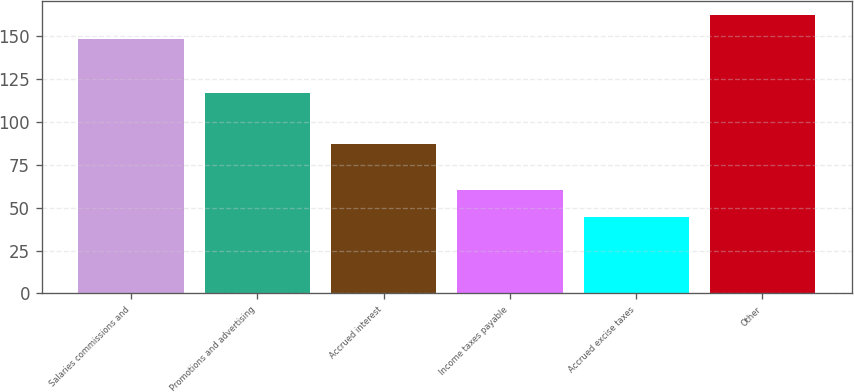Convert chart to OTSL. <chart><loc_0><loc_0><loc_500><loc_500><bar_chart><fcel>Salaries commissions and<fcel>Promotions and advertising<fcel>Accrued interest<fcel>Income taxes payable<fcel>Accrued excise taxes<fcel>Other<nl><fcel>148.5<fcel>116.9<fcel>87.5<fcel>60.2<fcel>44.6<fcel>162.7<nl></chart> 